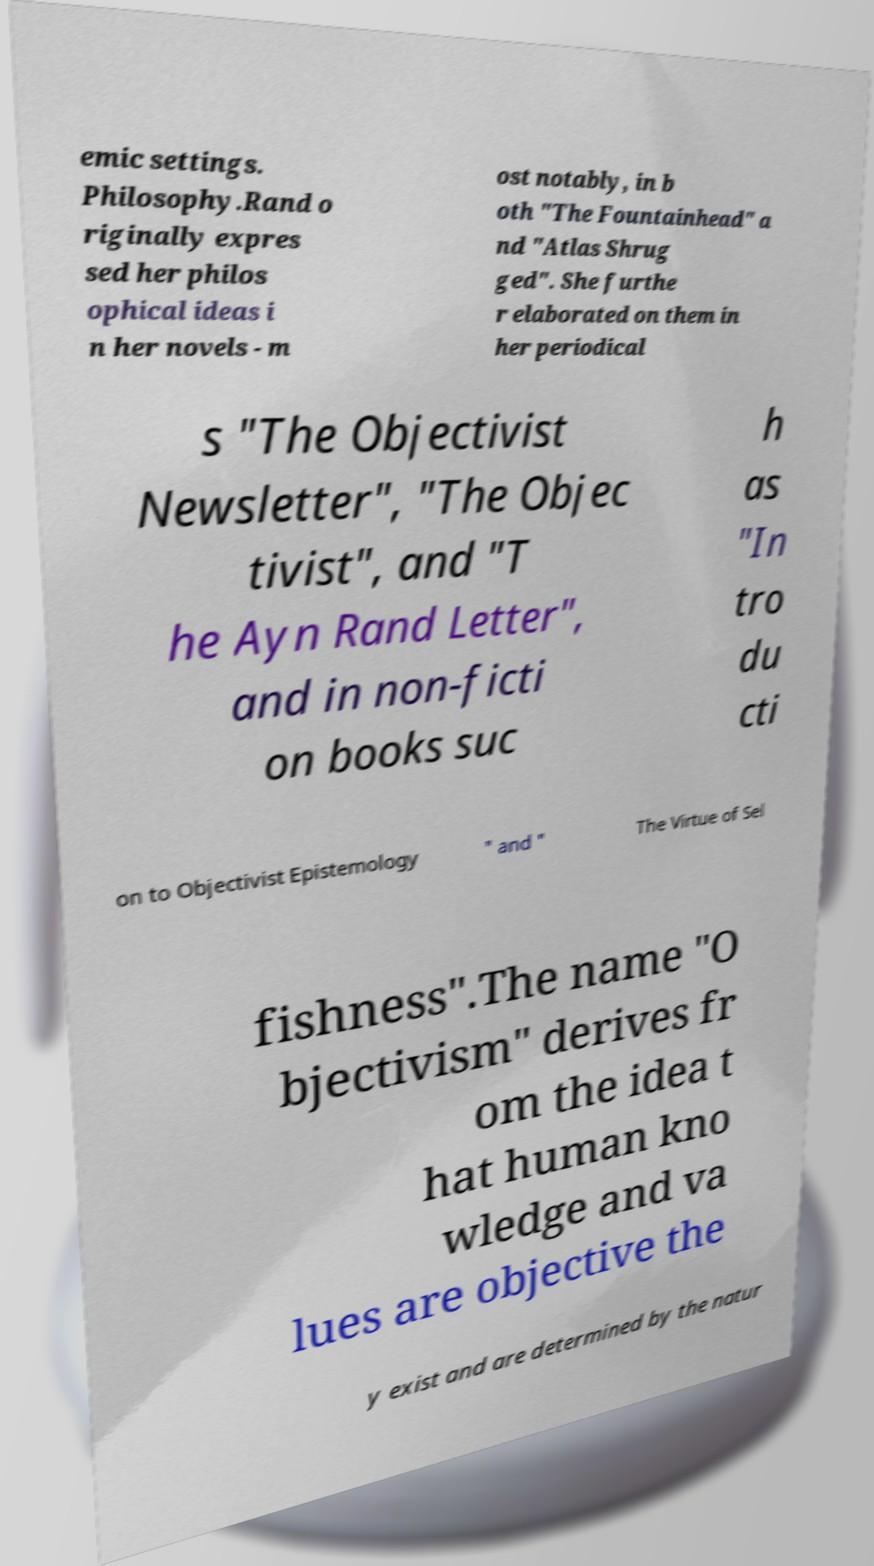I need the written content from this picture converted into text. Can you do that? emic settings. Philosophy.Rand o riginally expres sed her philos ophical ideas i n her novels - m ost notably, in b oth "The Fountainhead" a nd "Atlas Shrug ged". She furthe r elaborated on them in her periodical s "The Objectivist Newsletter", "The Objec tivist", and "T he Ayn Rand Letter", and in non-ficti on books suc h as "In tro du cti on to Objectivist Epistemology " and " The Virtue of Sel fishness".The name "O bjectivism" derives fr om the idea t hat human kno wledge and va lues are objective the y exist and are determined by the natur 